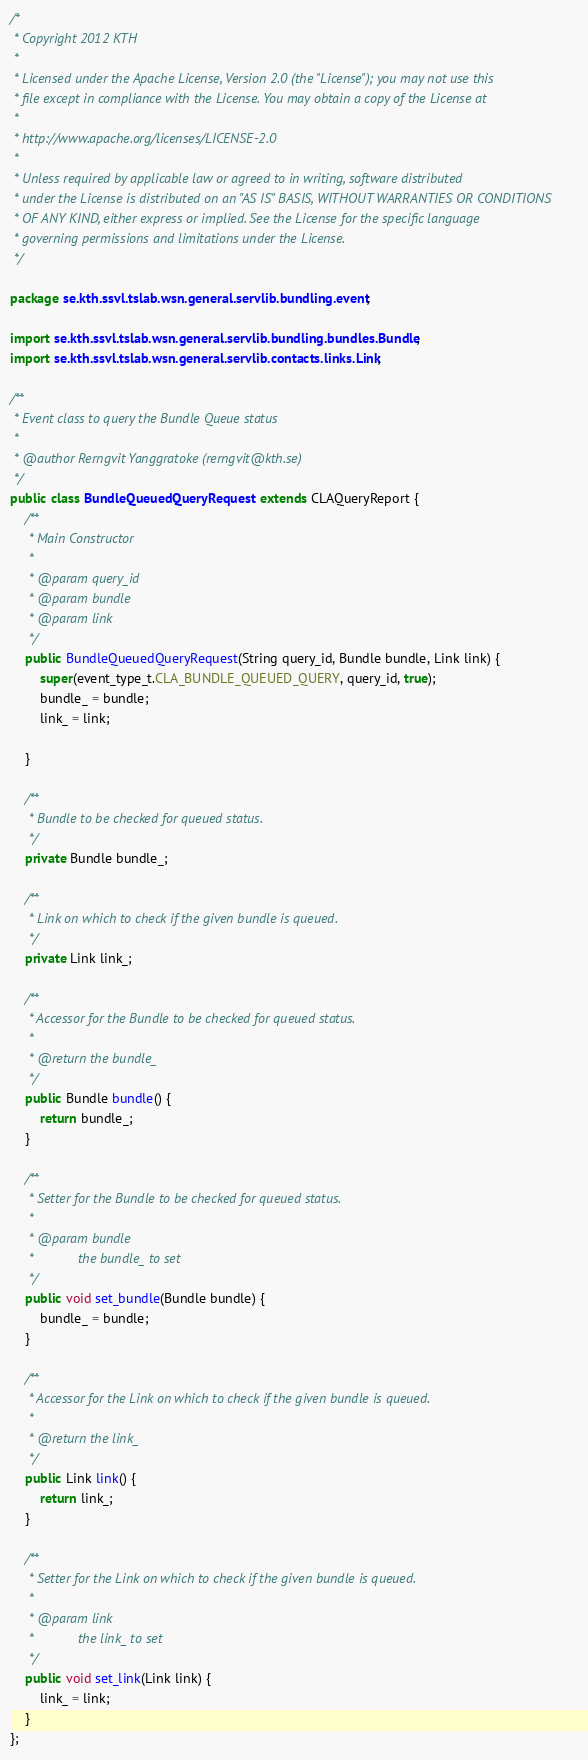<code> <loc_0><loc_0><loc_500><loc_500><_Java_>/*
 * Copyright 2012 KTH
 * 
 * Licensed under the Apache License, Version 2.0 (the "License"); you may not use this
 * file except in compliance with the License. You may obtain a copy of the License at
 * 
 * http://www.apache.org/licenses/LICENSE-2.0
 * 
 * Unless required by applicable law or agreed to in writing, software distributed
 * under the License is distributed on an "AS IS" BASIS, WITHOUT WARRANTIES OR CONDITIONS
 * OF ANY KIND, either express or implied. See the License for the specific language
 * governing permissions and limitations under the License.
 */

package se.kth.ssvl.tslab.wsn.general.servlib.bundling.event;

import se.kth.ssvl.tslab.wsn.general.servlib.bundling.bundles.Bundle;
import se.kth.ssvl.tslab.wsn.general.servlib.contacts.links.Link;

/**
 * Event class to query the Bundle Queue status
 * 
 * @author Rerngvit Yanggratoke (rerngvit@kth.se)
 */
public class BundleQueuedQueryRequest extends CLAQueryReport {
	/**
	 * Main Constructor
	 * 
	 * @param query_id
	 * @param bundle
	 * @param link
	 */
	public BundleQueuedQueryRequest(String query_id, Bundle bundle, Link link) {
		super(event_type_t.CLA_BUNDLE_QUEUED_QUERY, query_id, true);
		bundle_ = bundle;
		link_ = link;

	}

	/**
	 * Bundle to be checked for queued status.
	 */
	private Bundle bundle_;

	/**
	 * Link on which to check if the given bundle is queued.
	 */
	private Link link_;

	/**
	 * Accessor for the Bundle to be checked for queued status.
	 * 
	 * @return the bundle_
	 */
	public Bundle bundle() {
		return bundle_;
	}

	/**
	 * Setter for the Bundle to be checked for queued status.
	 * 
	 * @param bundle
	 *            the bundle_ to set
	 */
	public void set_bundle(Bundle bundle) {
		bundle_ = bundle;
	}

	/**
	 * Accessor for the Link on which to check if the given bundle is queued.
	 * 
	 * @return the link_
	 */
	public Link link() {
		return link_;
	}

	/**
	 * Setter for the Link on which to check if the given bundle is queued.
	 * 
	 * @param link
	 *            the link_ to set
	 */
	public void set_link(Link link) {
		link_ = link;
	}
};</code> 